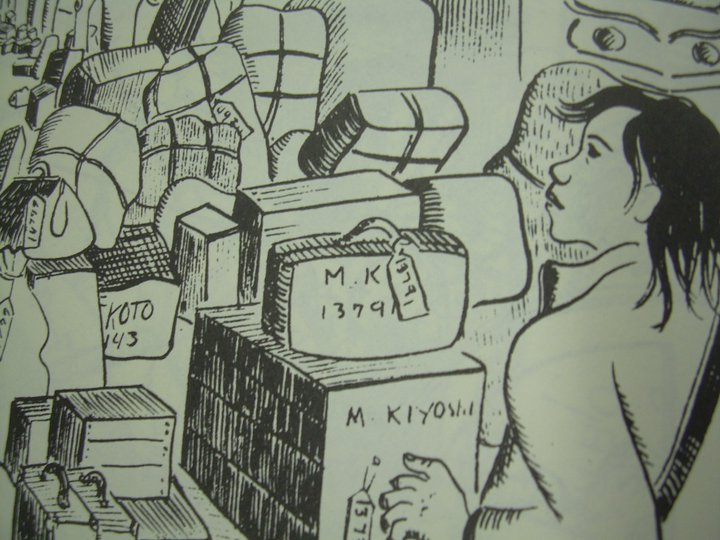How does the presence and expression of the woman relate to the rest of the objects depicted in the image? The woman's indirect gaze away from the array of packed and labeled objects introduces a nuanced layer to the image, subtly hinting at reflection or disconnection. This contemplative gesture, paired with the historical and personal items marked 'KYOTO 43' and 'M. Kiyoshi', suggests a deep narrative, potentially linked to historical migrations or personal displacement during conflict periods such as World War II. The unemotional yet thoughtful expression of the woman accentuates a poignant moment, possibly indicating her reminiscence or reconsideration of her past. The composition of the image, with her amidst many labeled belongings, underscores a personal and possibly burdensome journey, rich in memories and historical weight. 